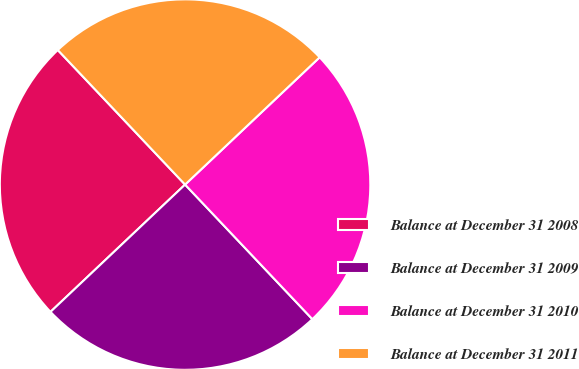<chart> <loc_0><loc_0><loc_500><loc_500><pie_chart><fcel>Balance at December 31 2008<fcel>Balance at December 31 2009<fcel>Balance at December 31 2010<fcel>Balance at December 31 2011<nl><fcel>25.0%<fcel>25.0%<fcel>25.0%<fcel>25.0%<nl></chart> 